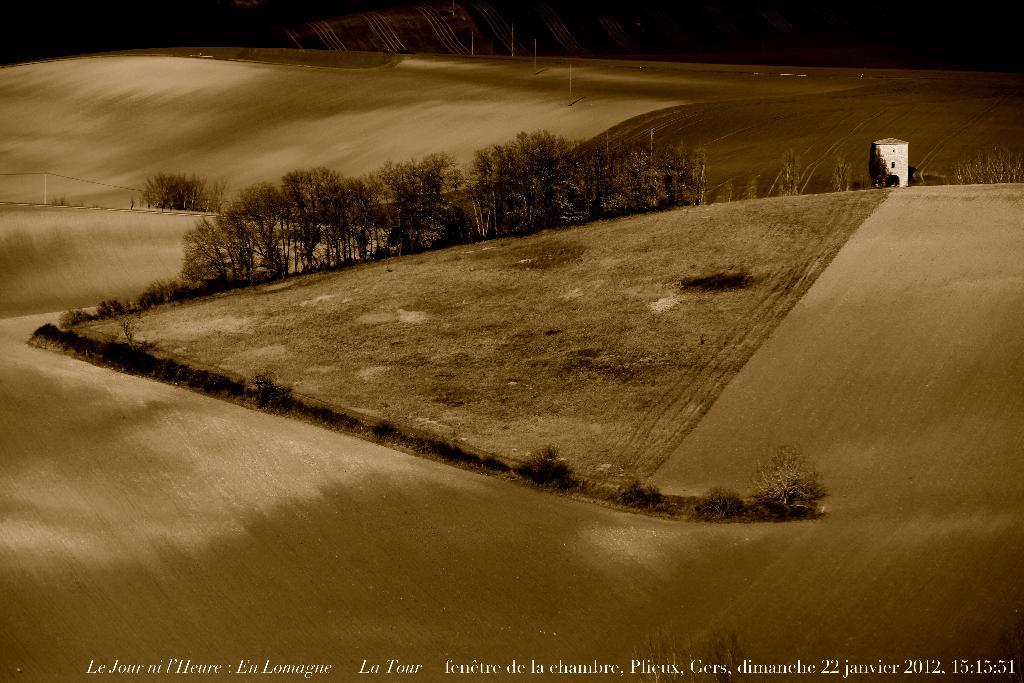What type of surface is visible in the image? There is ground visible in the image. What natural elements can be seen in the image? There are many trees in the image. Are there any man-made structures visible in the image? Yes, there is a building in the image. What is the color of the background in the image? The background of the image is black. How many sheep are visible in the image? There are no sheep present in the image. What type of bottle can be seen in the image? There is no bottle present in the image. 